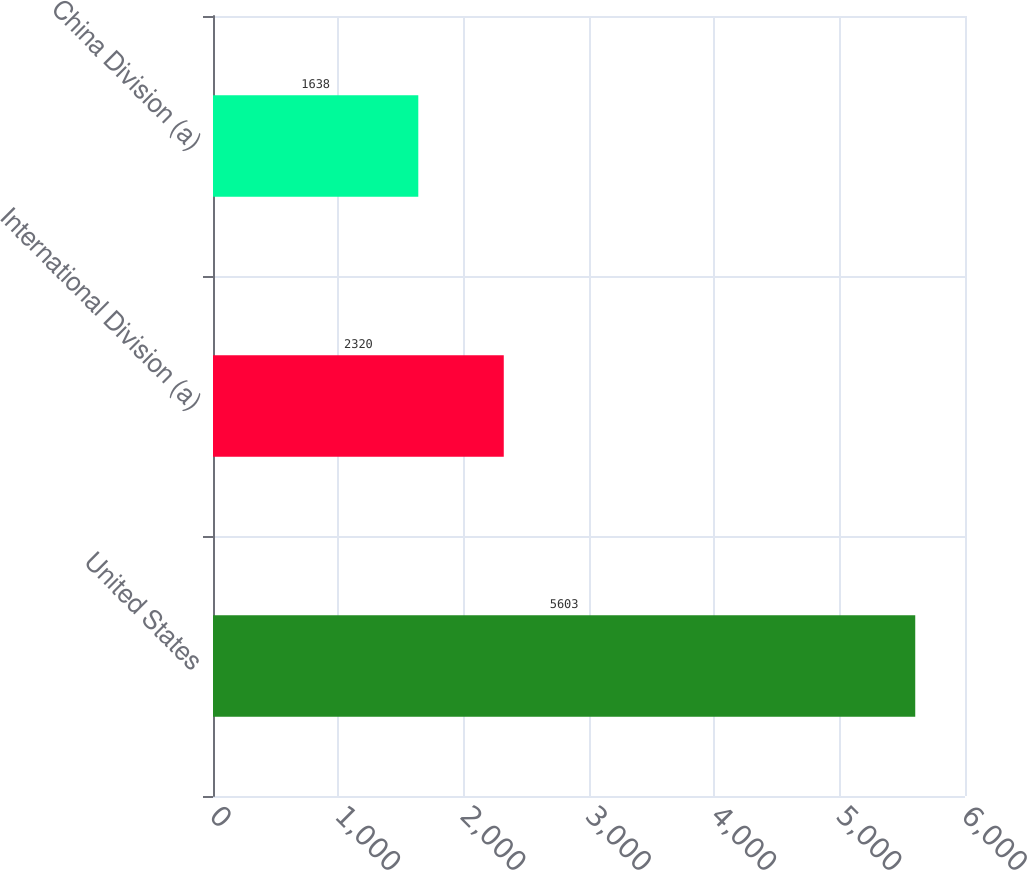Convert chart. <chart><loc_0><loc_0><loc_500><loc_500><bar_chart><fcel>United States<fcel>International Division (a)<fcel>China Division (a)<nl><fcel>5603<fcel>2320<fcel>1638<nl></chart> 